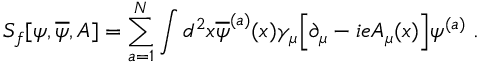Convert formula to latex. <formula><loc_0><loc_0><loc_500><loc_500>S _ { f } [ \psi , \overline { \psi } , A ] = \sum _ { a = 1 } ^ { N } \int d ^ { 2 } x \overline { \psi } ^ { ( a ) } ( x ) \gamma _ { \mu } \left [ \partial _ { \mu } - i e A _ { \mu } ( x ) \right ] \psi ^ { ( a ) } \, .</formula> 